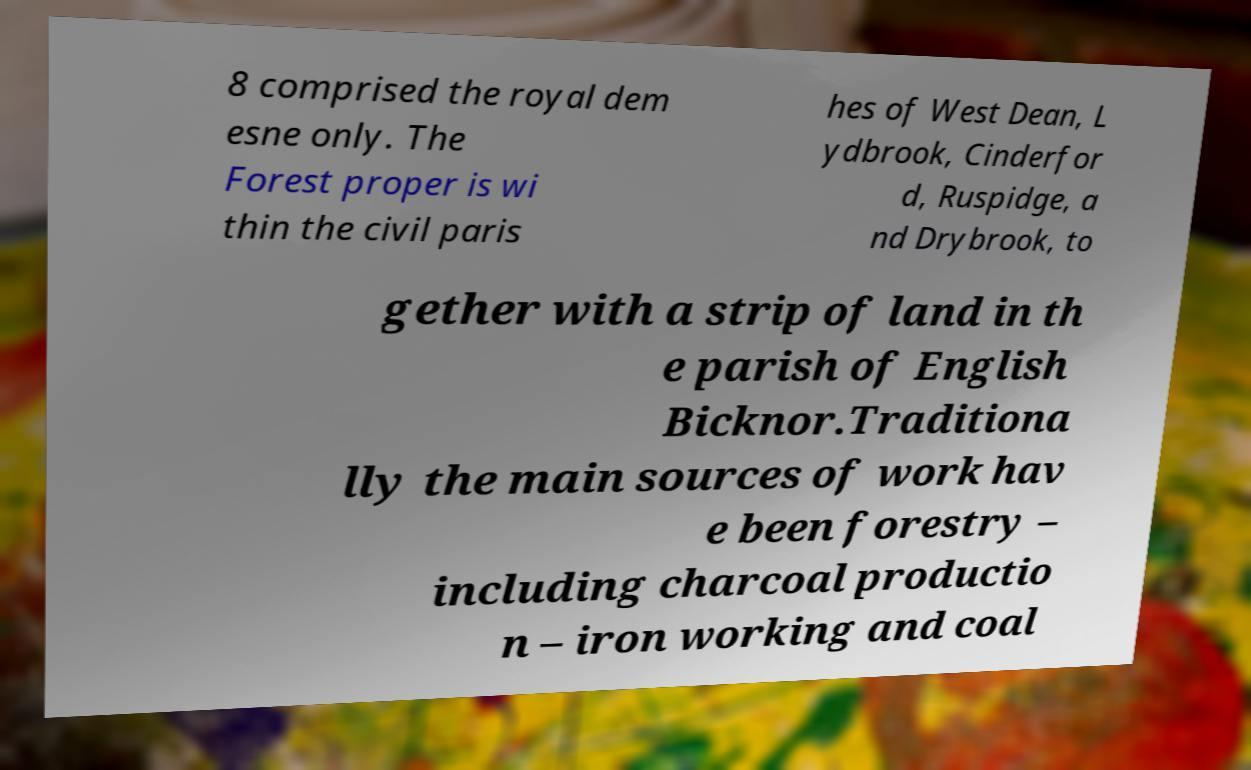Please identify and transcribe the text found in this image. 8 comprised the royal dem esne only. The Forest proper is wi thin the civil paris hes of West Dean, L ydbrook, Cinderfor d, Ruspidge, a nd Drybrook, to gether with a strip of land in th e parish of English Bicknor.Traditiona lly the main sources of work hav e been forestry – including charcoal productio n – iron working and coal 